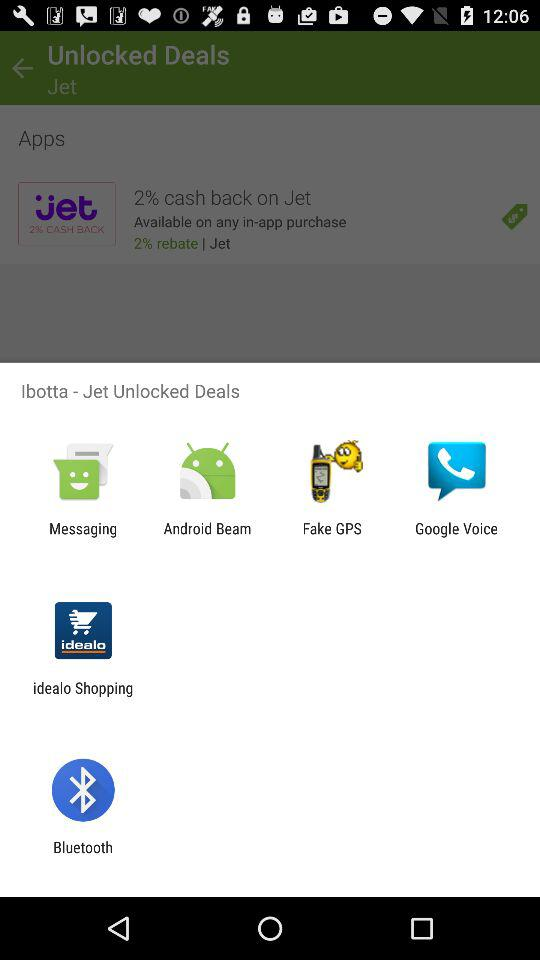Which applications can be used for sharing? The applications that can be used for sharing are "Messaging", "Android Beam", "Fake GPS", "Google Voice", "idealo Shopping" and "Bluetooth". 